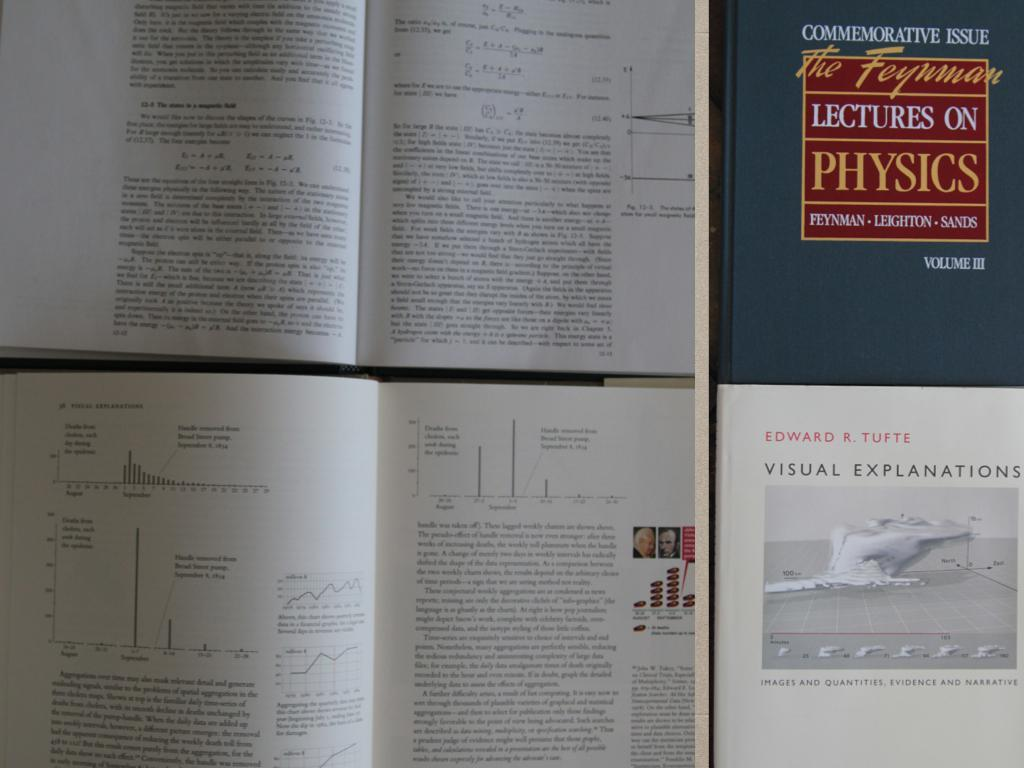Provide a one-sentence caption for the provided image. Multiple pages of a book are on display, one of the books on display is titled Lectures on Physics. 